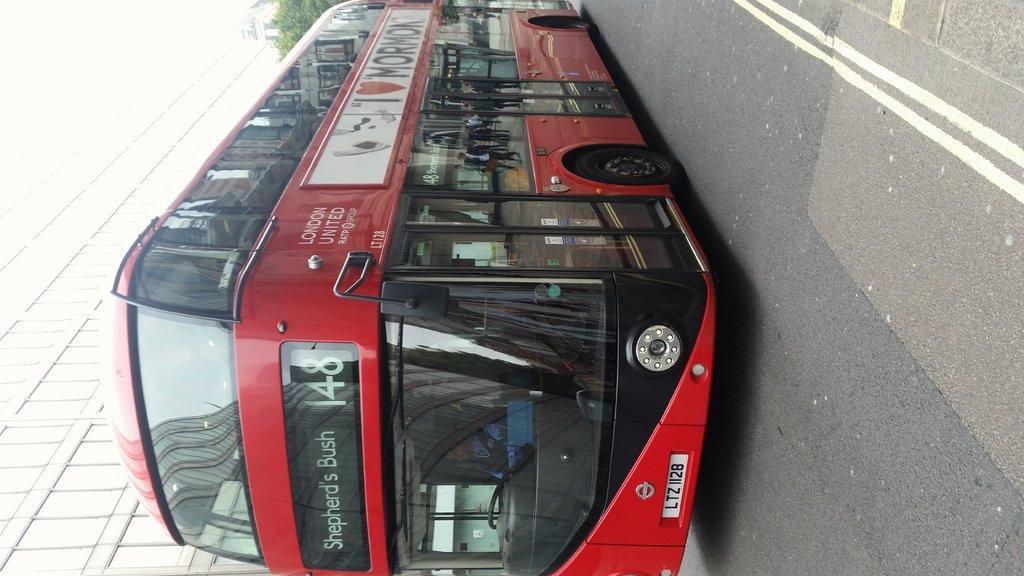How would you summarize this image in a sentence or two? In the center of the image there is a red color bus on the road. To the left side of the image there is a building. There is a tree. 